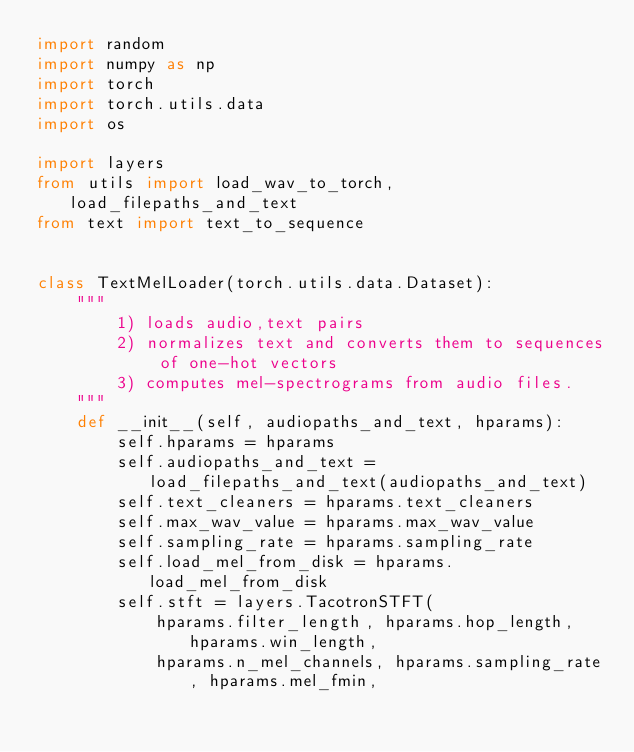<code> <loc_0><loc_0><loc_500><loc_500><_Python_>import random
import numpy as np
import torch
import torch.utils.data
import os

import layers
from utils import load_wav_to_torch, load_filepaths_and_text
from text import text_to_sequence


class TextMelLoader(torch.utils.data.Dataset):
    """
        1) loads audio,text pairs
        2) normalizes text and converts them to sequences of one-hot vectors
        3) computes mel-spectrograms from audio files.
    """
    def __init__(self, audiopaths_and_text, hparams):
        self.hparams = hparams
        self.audiopaths_and_text = load_filepaths_and_text(audiopaths_and_text)
        self.text_cleaners = hparams.text_cleaners
        self.max_wav_value = hparams.max_wav_value
        self.sampling_rate = hparams.sampling_rate
        self.load_mel_from_disk = hparams.load_mel_from_disk
        self.stft = layers.TacotronSTFT(
            hparams.filter_length, hparams.hop_length, hparams.win_length,
            hparams.n_mel_channels, hparams.sampling_rate, hparams.mel_fmin,</code> 